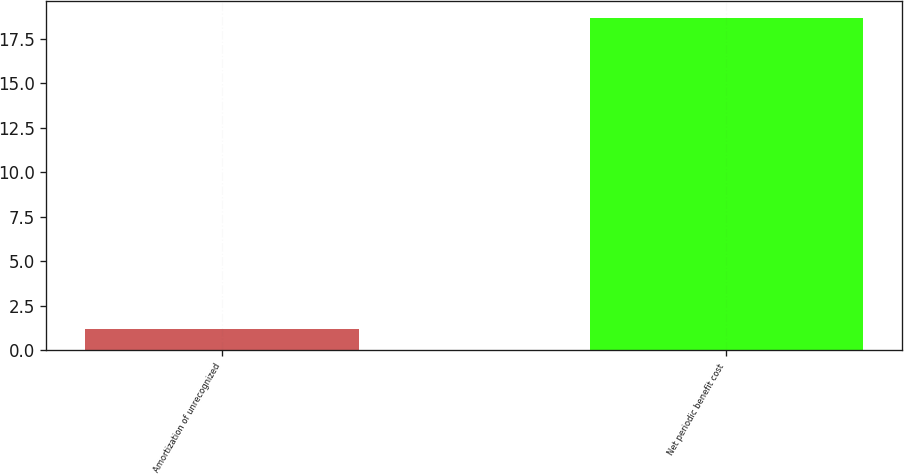<chart> <loc_0><loc_0><loc_500><loc_500><bar_chart><fcel>Amortization of unrecognized<fcel>Net periodic benefit cost<nl><fcel>1.2<fcel>18.7<nl></chart> 